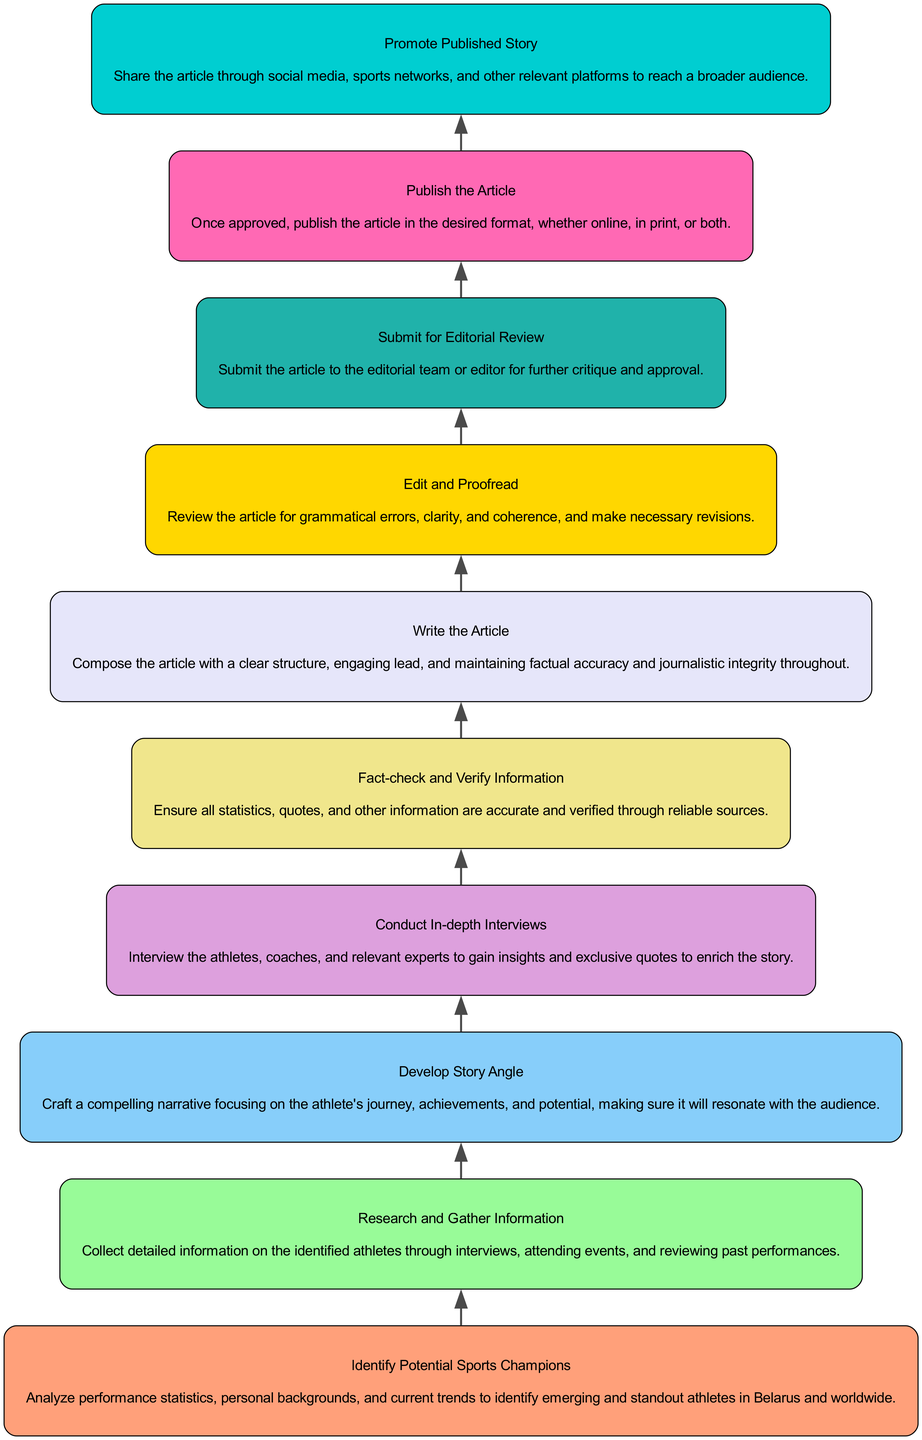What is the first step in the flowchart? The flowchart begins with the first step labeled as "Identify Potential Sports Champions," which focuses on analyzing athletes.
Answer: Identify Potential Sports Champions How many steps are in the flowchart? By counting each node in the flowchart, we find there are a total of ten steps represented.
Answer: 10 What connects "Fact-check and Verify Information" to "Write the Article"? The relationship between these two steps is direct; "Fact-check and Verify Information" feeds into "Write the Article," indicating that writing follows the verification of the information.
Answer: Edge What is the last step in the diagram? The flowchart concludes with the last step called "Promote Published Story," focusing on sharing the article after it is published.
Answer: Promote Published Story Which step comes immediately after "Develop Story Angle"? After "Develop Story Angle" in the sequence, the next step is "Conduct In-depth Interviews," indicating that narrative crafting is followed by gathering insights through interviews.
Answer: Conduct In-depth Interviews In what step do you ensure the accuracy of quotes? The step that focuses on ensuring the accuracy of quotes, statistics, and all other information is labeled "Fact-check and Verify Information."
Answer: Fact-check and Verify Information What is the relationship between "Submit for Editorial Review" and "Publish the Article"? "Submit for Editorial Review" precedes "Publish the Article," indicating that the article must be reviewed and approved before it can be published.
Answer: Submit for Editorial Review leads to Publish the Article How does the flowchart symbolize the progression of a sports story report? The flowchart illustrates a linear progression, meaning each step leads to the next in a structured order, removing redundancy and ensuring logical succession from the initial idea to publication.
Answer: Linear progression What role does "Edit and Proofread" play in the flowchart? "Edit and Proofread" acts as a crucial step before the article is submitted for editorial review, ensuring that the content is polished and free from errors.
Answer: Critical step before submission 